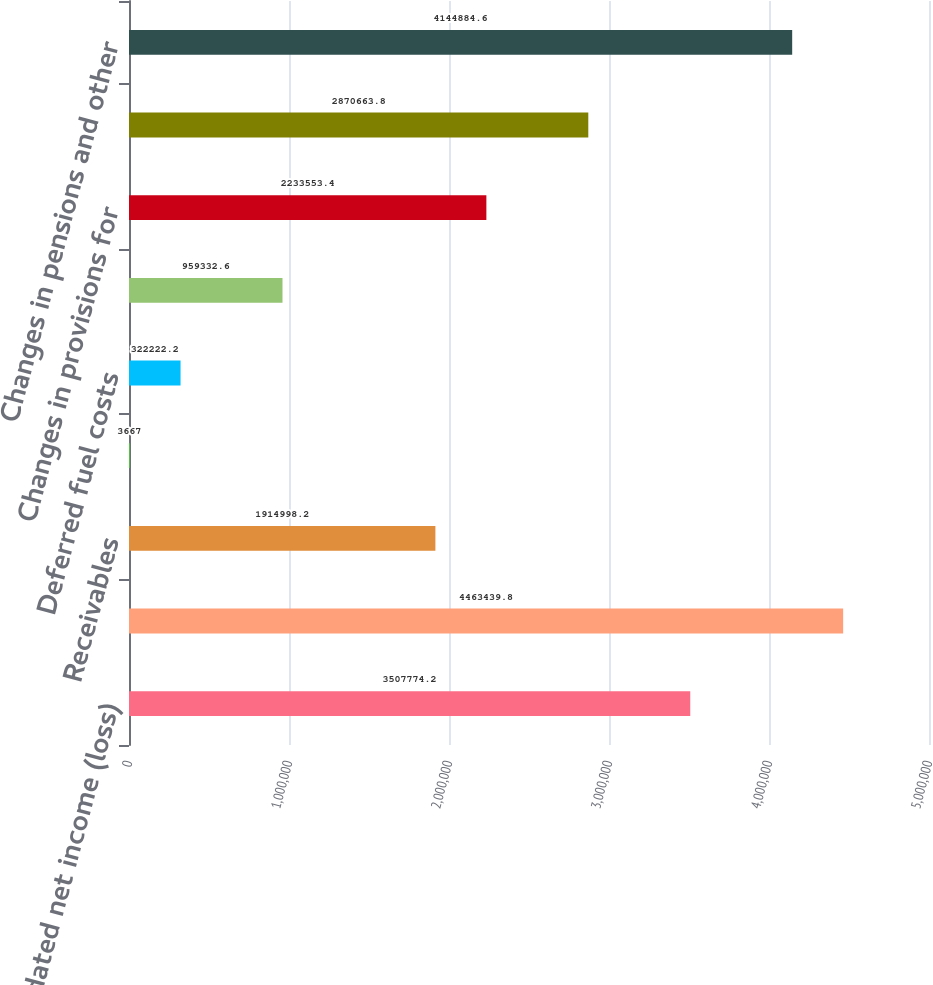Convert chart. <chart><loc_0><loc_0><loc_500><loc_500><bar_chart><fcel>Consolidated net income (loss)<fcel>flow provided by operating<fcel>Receivables<fcel>Interest accrued<fcel>Deferred fuel costs<fcel>Other working capital accounts<fcel>Changes in provisions for<fcel>Changes in other regulatory<fcel>Changes in pensions and other<nl><fcel>3.50777e+06<fcel>4.46344e+06<fcel>1.915e+06<fcel>3667<fcel>322222<fcel>959333<fcel>2.23355e+06<fcel>2.87066e+06<fcel>4.14488e+06<nl></chart> 